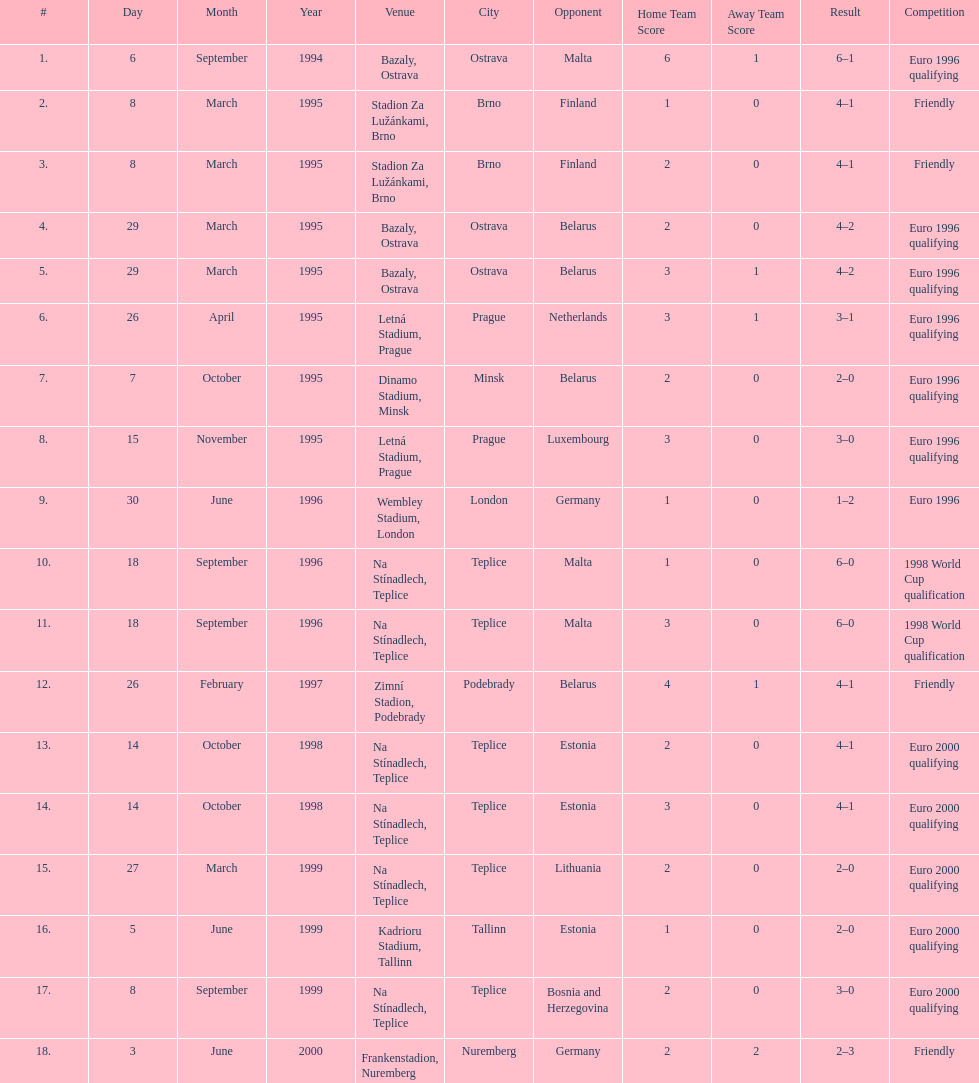How many total games took place in 1999? 3. 